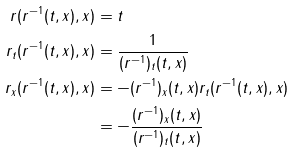<formula> <loc_0><loc_0><loc_500><loc_500>r ( r ^ { - 1 } ( t , x ) , x ) & = t \\ r _ { t } ( r ^ { - 1 } ( t , x ) , x ) & = \frac { 1 } { ( r ^ { - 1 } ) _ { t } ( t , x ) } \\ r _ { x } ( r ^ { - 1 } ( t , x ) , x ) & = - ( r ^ { - 1 } ) _ { x } ( t , x ) r _ { t } ( r ^ { - 1 } ( t , x ) , x ) \\ & = - \frac { ( r ^ { - 1 } ) _ { x } ( t , x ) } { ( r ^ { - 1 } ) _ { t } ( t , x ) }</formula> 